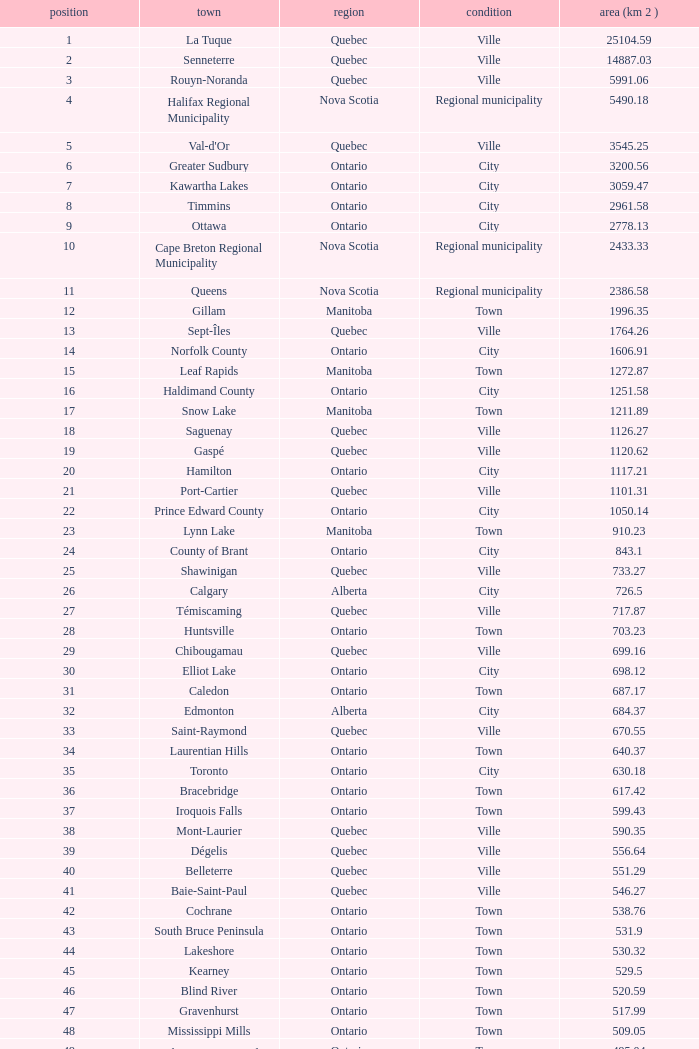What is the highest Area (KM 2) for the Province of Ontario, that has the Status of Town, a Municipality of Minto, and a Rank that's smaller than 84? None. 